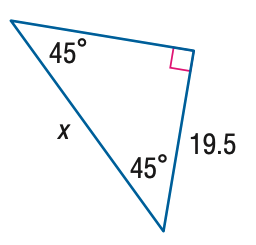Question: Find x.
Choices:
A. \frac { 39 \sqrt { 2 } } { 4 }
B. \frac { 39 \sqrt { 2 } } { 2 }
C. \frac { 39 \sqrt { 3 } } { 2 }
D. 39
Answer with the letter. Answer: B 